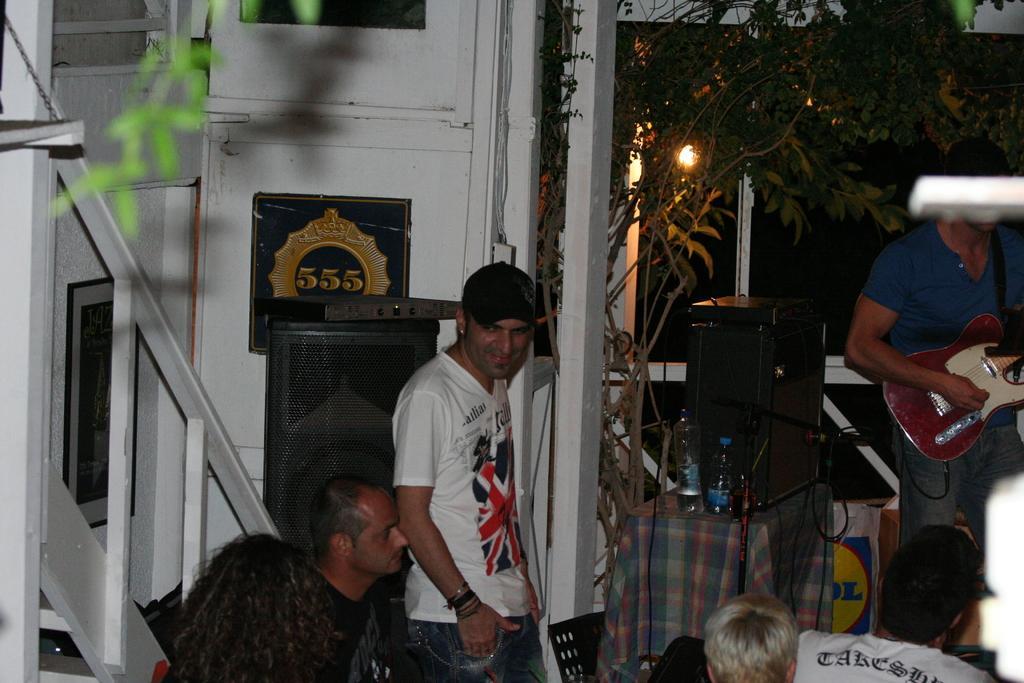Can you describe this image briefly? In this image i can see there are group of people among them the person on the right side is playing a guitar in his hands. I can also see there is a table with few bottles, a speaker and a tree. 